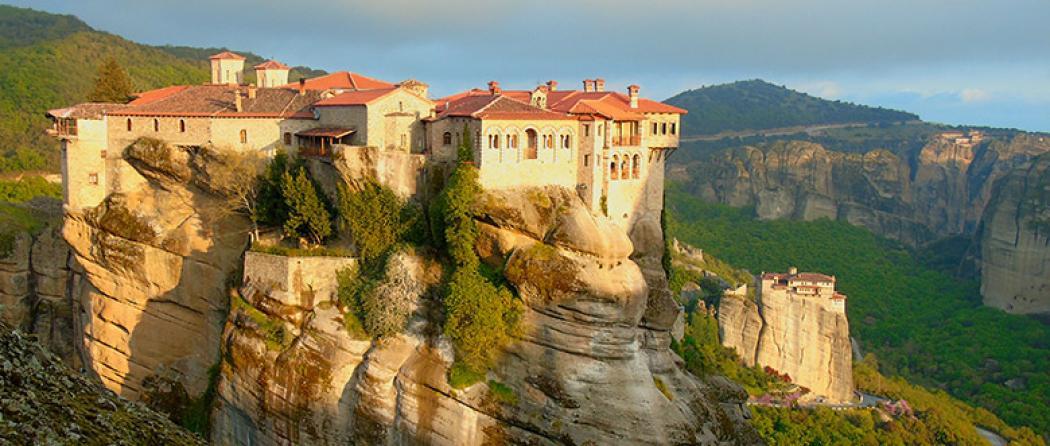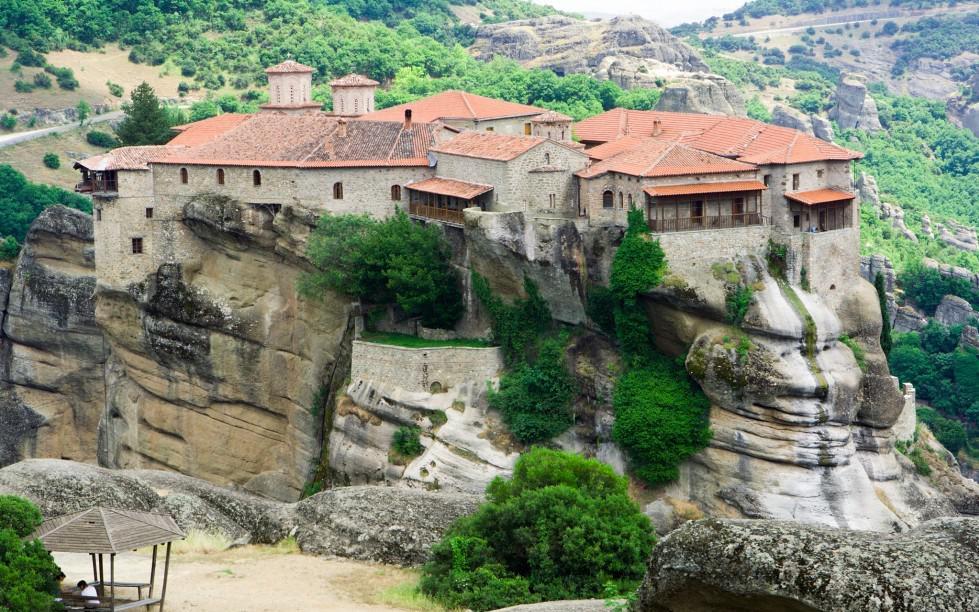The first image is the image on the left, the second image is the image on the right. For the images displayed, is the sentence "Right image features buildings with red-orange roofs on a rocky hilltop, while left image does not." factually correct? Answer yes or no. No. 